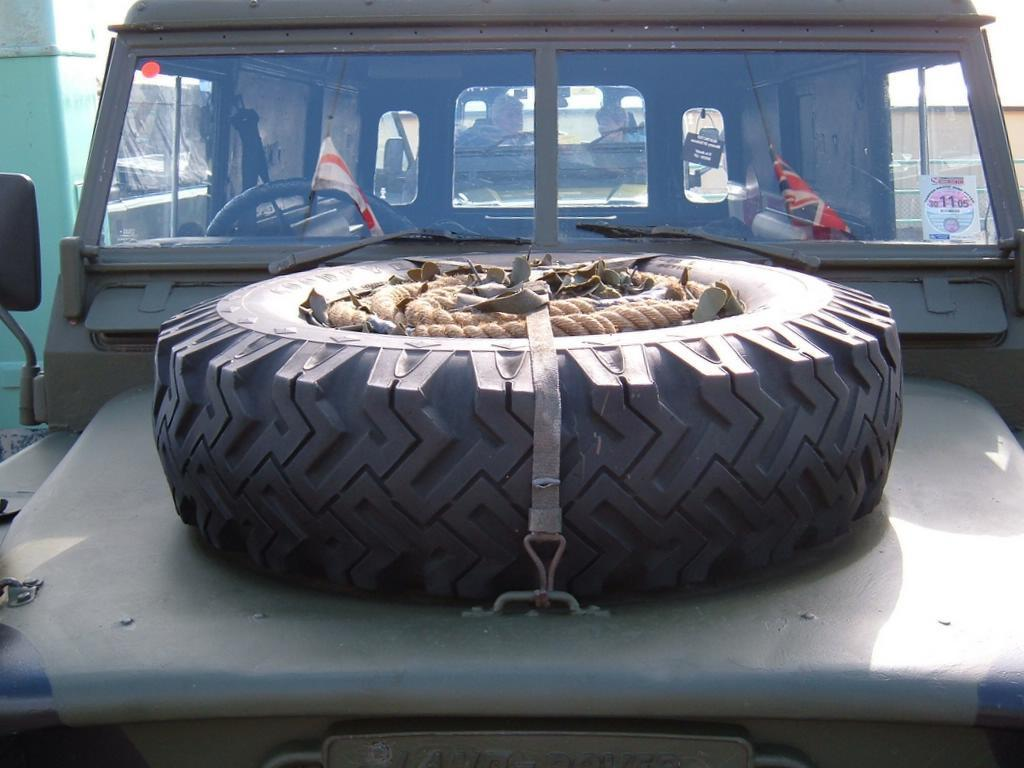What vehicle is present in the image? There is a jeep in the image. What can be seen inside the jeep? There are two flags inside the jeep. What is used to control the direction of the jeep? The jeep has a steering wheel. What is placed on top of the jeep? There is a tyre with a rope on top of the jeep. What structure is visible in the image? There is a building visible in the image. What type of argument is taking place between the two flags inside the jeep? There is no argument taking place between the two flags inside the jeep; they are simply flags. Can you see any bubbles floating around the jeep in the image? There are no bubbles visible in the image. 